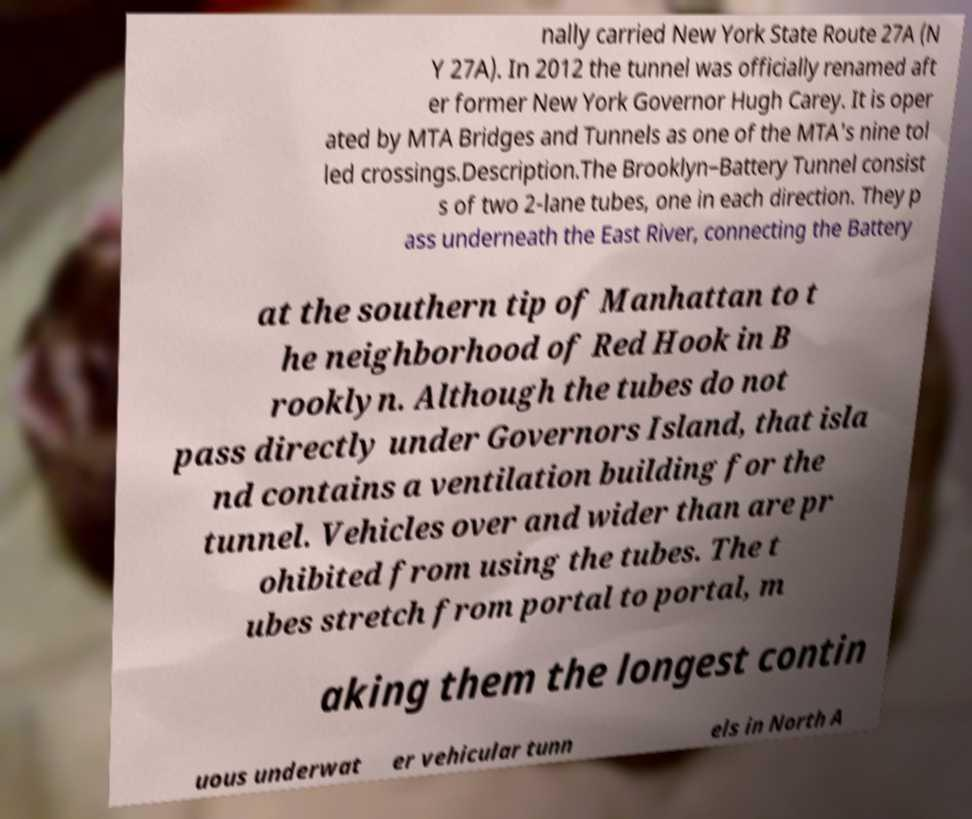For documentation purposes, I need the text within this image transcribed. Could you provide that? nally carried New York State Route 27A (N Y 27A). In 2012 the tunnel was officially renamed aft er former New York Governor Hugh Carey. It is oper ated by MTA Bridges and Tunnels as one of the MTA's nine tol led crossings.Description.The Brooklyn–Battery Tunnel consist s of two 2-lane tubes, one in each direction. They p ass underneath the East River, connecting the Battery at the southern tip of Manhattan to t he neighborhood of Red Hook in B rooklyn. Although the tubes do not pass directly under Governors Island, that isla nd contains a ventilation building for the tunnel. Vehicles over and wider than are pr ohibited from using the tubes. The t ubes stretch from portal to portal, m aking them the longest contin uous underwat er vehicular tunn els in North A 